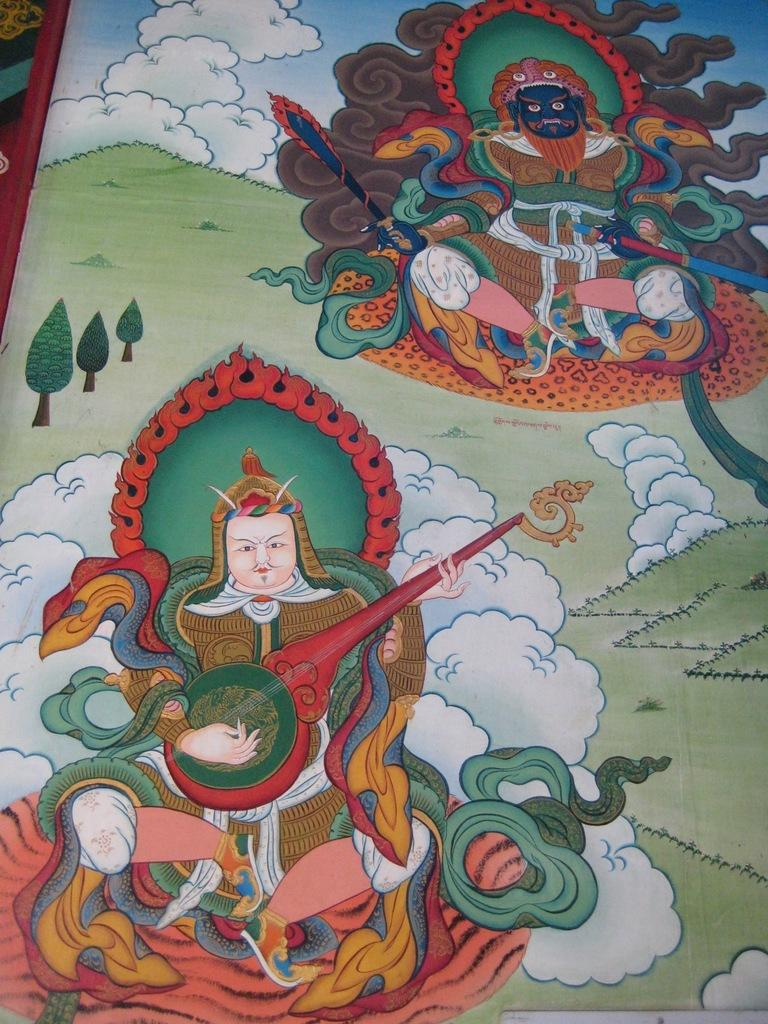What is the main subject of the image? There is a painting in the image. What are the people in the painting doing? The painting contains people holding musical instruments and people holding swords. What type of natural environment is visible in the image? There is grass visible in the image. What is visible in the background of the image? The sky is visible in the image. What type of pie is being served in the image? There is no pie present in the image; it features a painting with people holding musical instruments and swords. How many people are showing their emotions in the image? The question is unclear and cannot be answered definitively based on the provided facts. The image features a painting with people holding musical instruments and swords, but it does not specify their emotions or the number of people showing emotions. 